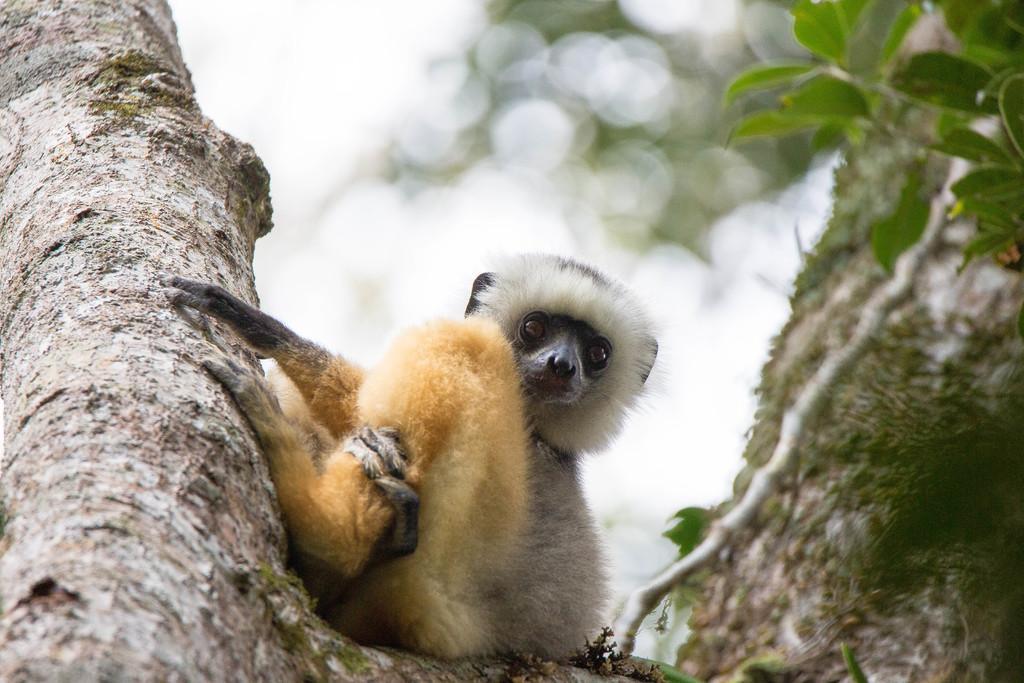How would you summarize this image in a sentence or two? This image is taken outdoors. At the bottom of the image there is a tree. At the top of the image there is the sky and there are few green leaves. In the middle of the image there is baby diademed sifaka on the branch of a tree. 